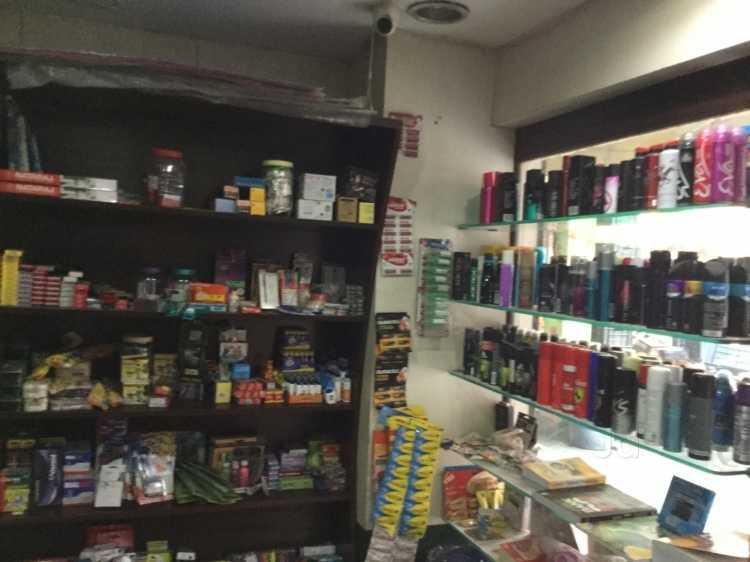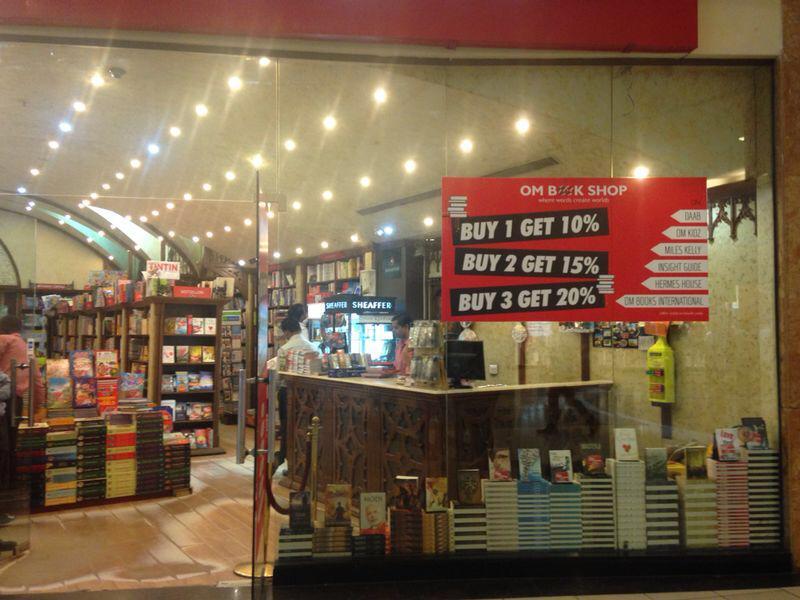The first image is the image on the left, the second image is the image on the right. Considering the images on both sides, is "There is no human inside a store in the left image." valid? Answer yes or no. Yes. The first image is the image on the left, the second image is the image on the right. Analyze the images presented: Is the assertion "The signage for the store can only be seen in one of the images." valid? Answer yes or no. Yes. 